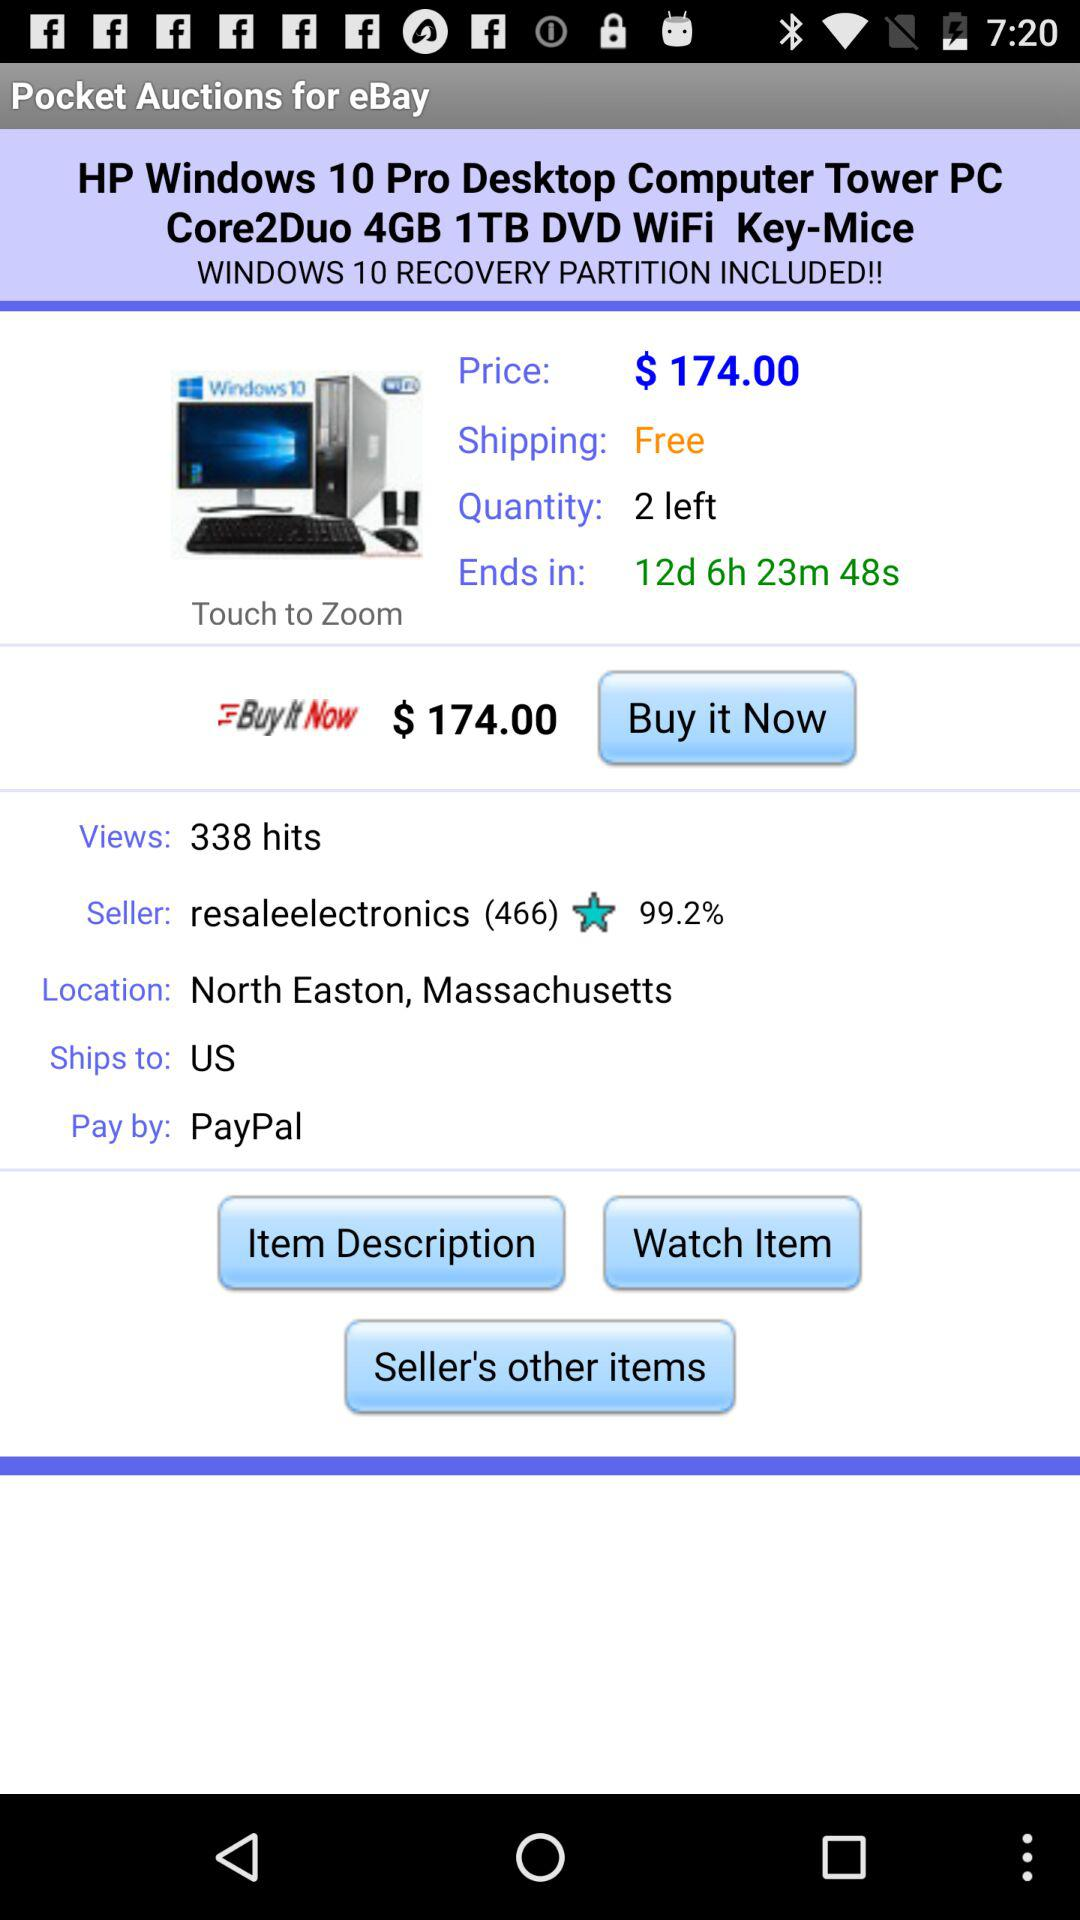Who is the seller of "HP Windows 10 Pro Desktop Computer Tower PC"? The seller of "HP Windows 10 Pro Desktop Computer Tower PC" is "resaleelectronics". 